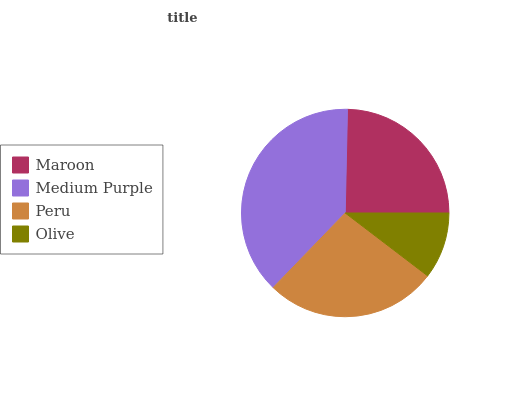Is Olive the minimum?
Answer yes or no. Yes. Is Medium Purple the maximum?
Answer yes or no. Yes. Is Peru the minimum?
Answer yes or no. No. Is Peru the maximum?
Answer yes or no. No. Is Medium Purple greater than Peru?
Answer yes or no. Yes. Is Peru less than Medium Purple?
Answer yes or no. Yes. Is Peru greater than Medium Purple?
Answer yes or no. No. Is Medium Purple less than Peru?
Answer yes or no. No. Is Peru the high median?
Answer yes or no. Yes. Is Maroon the low median?
Answer yes or no. Yes. Is Maroon the high median?
Answer yes or no. No. Is Olive the low median?
Answer yes or no. No. 